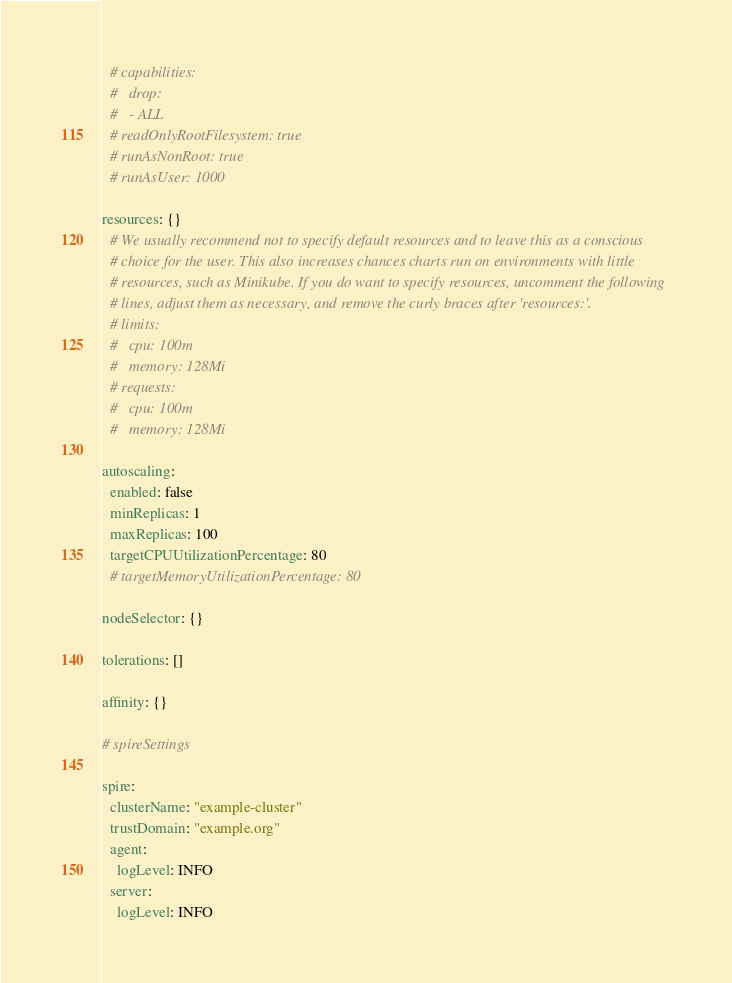<code> <loc_0><loc_0><loc_500><loc_500><_YAML_>  # capabilities:
  #   drop:
  #   - ALL
  # readOnlyRootFilesystem: true
  # runAsNonRoot: true
  # runAsUser: 1000

resources: {}
  # We usually recommend not to specify default resources and to leave this as a conscious
  # choice for the user. This also increases chances charts run on environments with little
  # resources, such as Minikube. If you do want to specify resources, uncomment the following
  # lines, adjust them as necessary, and remove the curly braces after 'resources:'.
  # limits:
  #   cpu: 100m
  #   memory: 128Mi
  # requests:
  #   cpu: 100m
  #   memory: 128Mi

autoscaling:
  enabled: false
  minReplicas: 1
  maxReplicas: 100
  targetCPUUtilizationPercentage: 80
  # targetMemoryUtilizationPercentage: 80

nodeSelector: {}

tolerations: []

affinity: {}

# spireSettings

spire:
  clusterName: "example-cluster"
  trustDomain: "example.org"
  agent:
    logLevel: INFO
  server:
    logLevel: INFO
</code> 